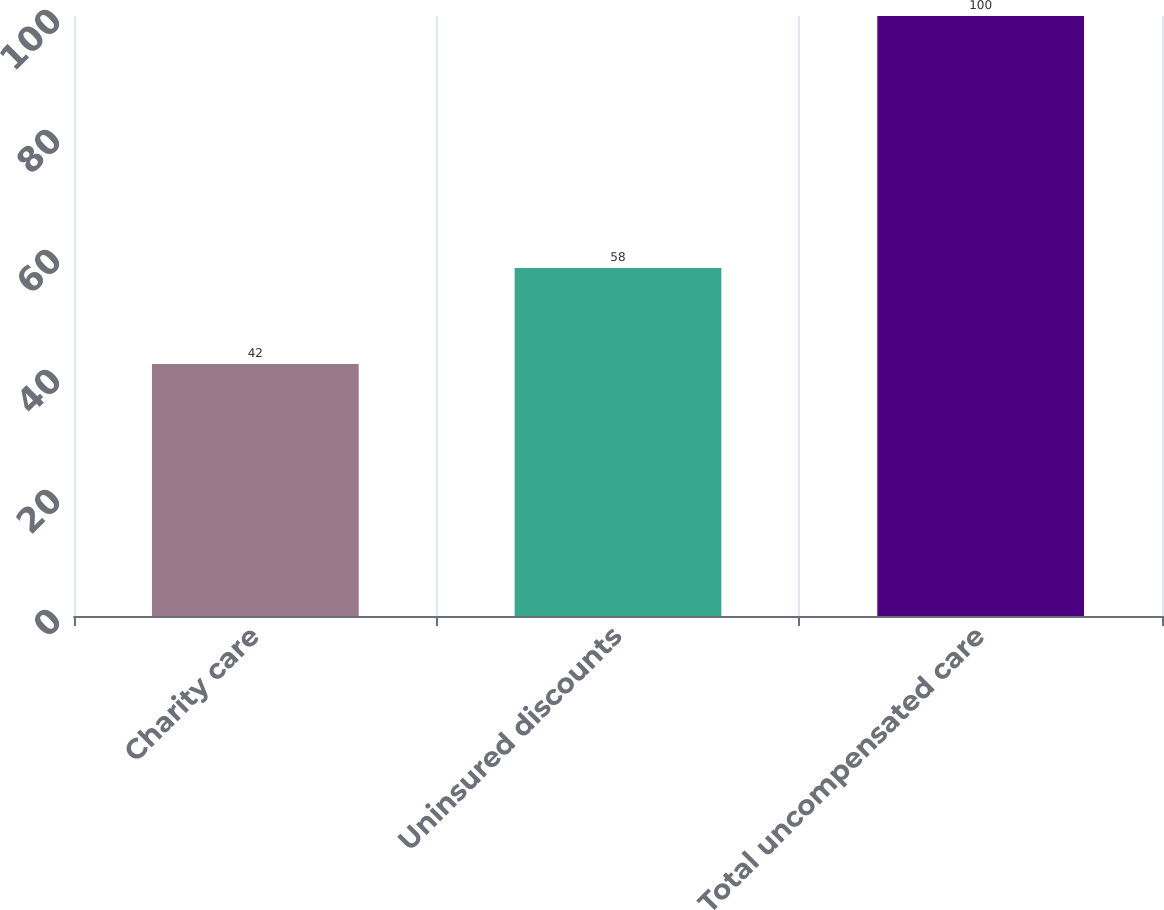<chart> <loc_0><loc_0><loc_500><loc_500><bar_chart><fcel>Charity care<fcel>Uninsured discounts<fcel>Total uncompensated care<nl><fcel>42<fcel>58<fcel>100<nl></chart> 